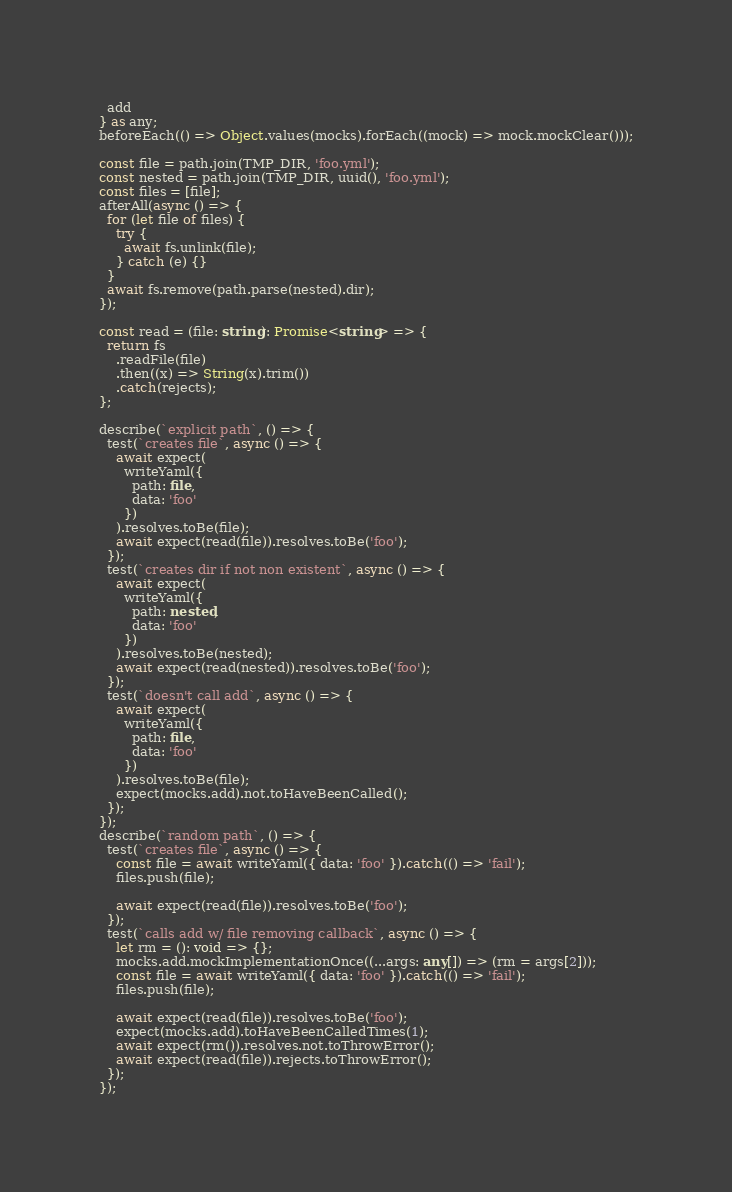Convert code to text. <code><loc_0><loc_0><loc_500><loc_500><_TypeScript_>  add
} as any;
beforeEach(() => Object.values(mocks).forEach((mock) => mock.mockClear()));

const file = path.join(TMP_DIR, 'foo.yml');
const nested = path.join(TMP_DIR, uuid(), 'foo.yml');
const files = [file];
afterAll(async () => {
  for (let file of files) {
    try {
      await fs.unlink(file);
    } catch (e) {}
  }
  await fs.remove(path.parse(nested).dir);
});

const read = (file: string): Promise<string> => {
  return fs
    .readFile(file)
    .then((x) => String(x).trim())
    .catch(rejects);
};

describe(`explicit path`, () => {
  test(`creates file`, async () => {
    await expect(
      writeYaml({
        path: file,
        data: 'foo'
      })
    ).resolves.toBe(file);
    await expect(read(file)).resolves.toBe('foo');
  });
  test(`creates dir if not non existent`, async () => {
    await expect(
      writeYaml({
        path: nested,
        data: 'foo'
      })
    ).resolves.toBe(nested);
    await expect(read(nested)).resolves.toBe('foo');
  });
  test(`doesn't call add`, async () => {
    await expect(
      writeYaml({
        path: file,
        data: 'foo'
      })
    ).resolves.toBe(file);
    expect(mocks.add).not.toHaveBeenCalled();
  });
});
describe(`random path`, () => {
  test(`creates file`, async () => {
    const file = await writeYaml({ data: 'foo' }).catch(() => 'fail');
    files.push(file);

    await expect(read(file)).resolves.toBe('foo');
  });
  test(`calls add w/ file removing callback`, async () => {
    let rm = (): void => {};
    mocks.add.mockImplementationOnce((...args: any[]) => (rm = args[2]));
    const file = await writeYaml({ data: 'foo' }).catch(() => 'fail');
    files.push(file);

    await expect(read(file)).resolves.toBe('foo');
    expect(mocks.add).toHaveBeenCalledTimes(1);
    await expect(rm()).resolves.not.toThrowError();
    await expect(read(file)).rejects.toThrowError();
  });
});
</code> 